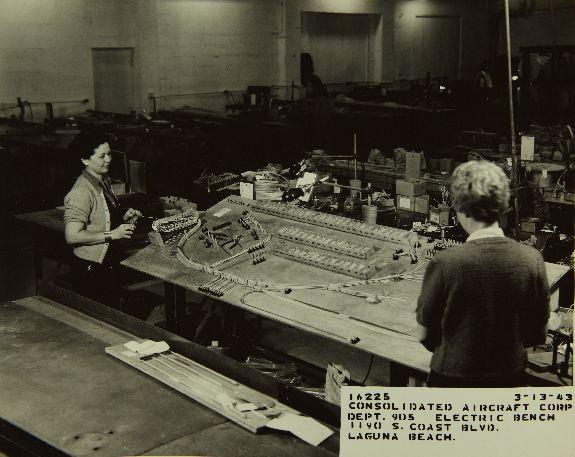What color is the photo?
Quick response, please. Black and white. Is this table in a cafeteria?
Give a very brief answer. No. Is this an older photo?
Write a very short answer. Yes. 